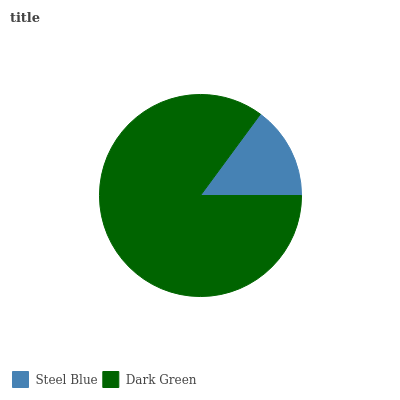Is Steel Blue the minimum?
Answer yes or no. Yes. Is Dark Green the maximum?
Answer yes or no. Yes. Is Dark Green the minimum?
Answer yes or no. No. Is Dark Green greater than Steel Blue?
Answer yes or no. Yes. Is Steel Blue less than Dark Green?
Answer yes or no. Yes. Is Steel Blue greater than Dark Green?
Answer yes or no. No. Is Dark Green less than Steel Blue?
Answer yes or no. No. Is Dark Green the high median?
Answer yes or no. Yes. Is Steel Blue the low median?
Answer yes or no. Yes. Is Steel Blue the high median?
Answer yes or no. No. Is Dark Green the low median?
Answer yes or no. No. 